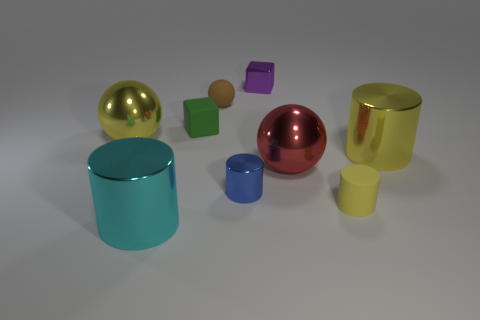Subtract all large red balls. How many balls are left? 2 Subtract all brown spheres. How many yellow cylinders are left? 2 Subtract all yellow cylinders. How many cylinders are left? 2 Subtract 1 spheres. How many spheres are left? 2 Subtract all cylinders. How many objects are left? 5 Subtract 0 purple cylinders. How many objects are left? 9 Subtract all purple spheres. Subtract all cyan blocks. How many spheres are left? 3 Subtract all yellow rubber cylinders. Subtract all yellow rubber objects. How many objects are left? 7 Add 3 green things. How many green things are left? 4 Add 3 tiny blue metallic things. How many tiny blue metallic things exist? 4 